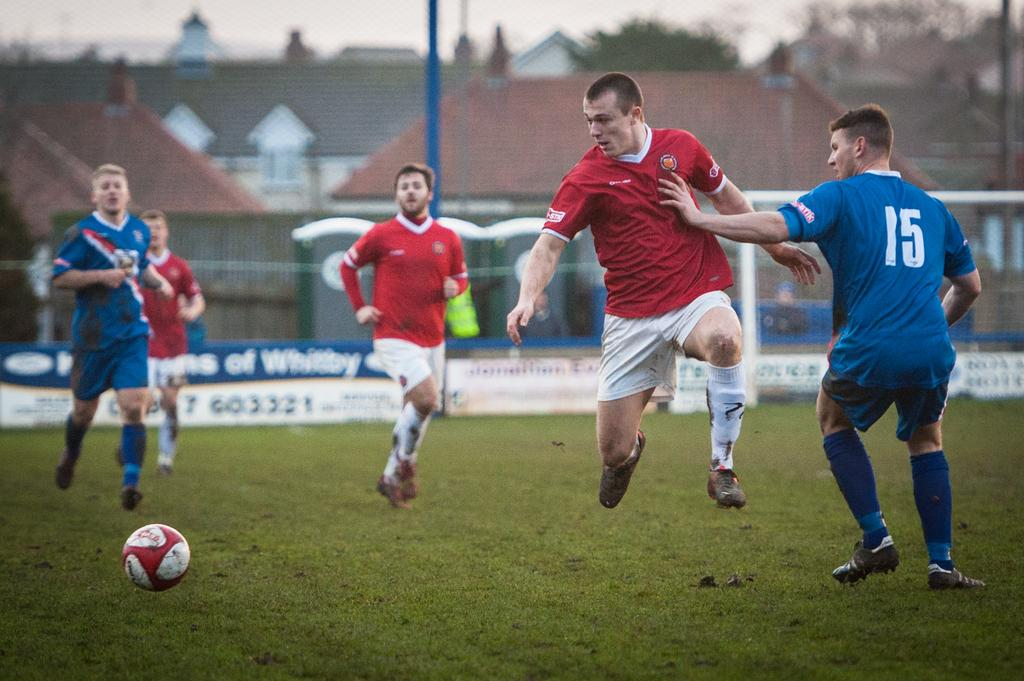<image>
Provide a brief description of the given image. Number 15 from teh blue team puts his hand out to stop a red team player 